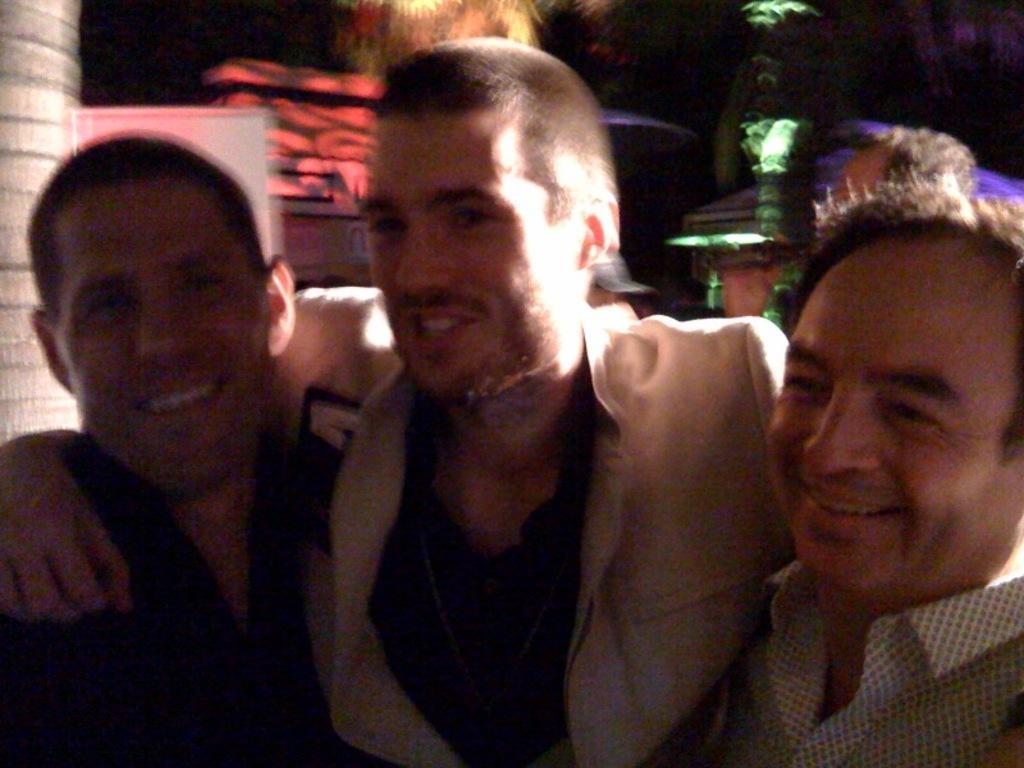Could you give a brief overview of what you see in this image? In this picture I can see few persons holding each other, behind there are some colorful lights focus. 